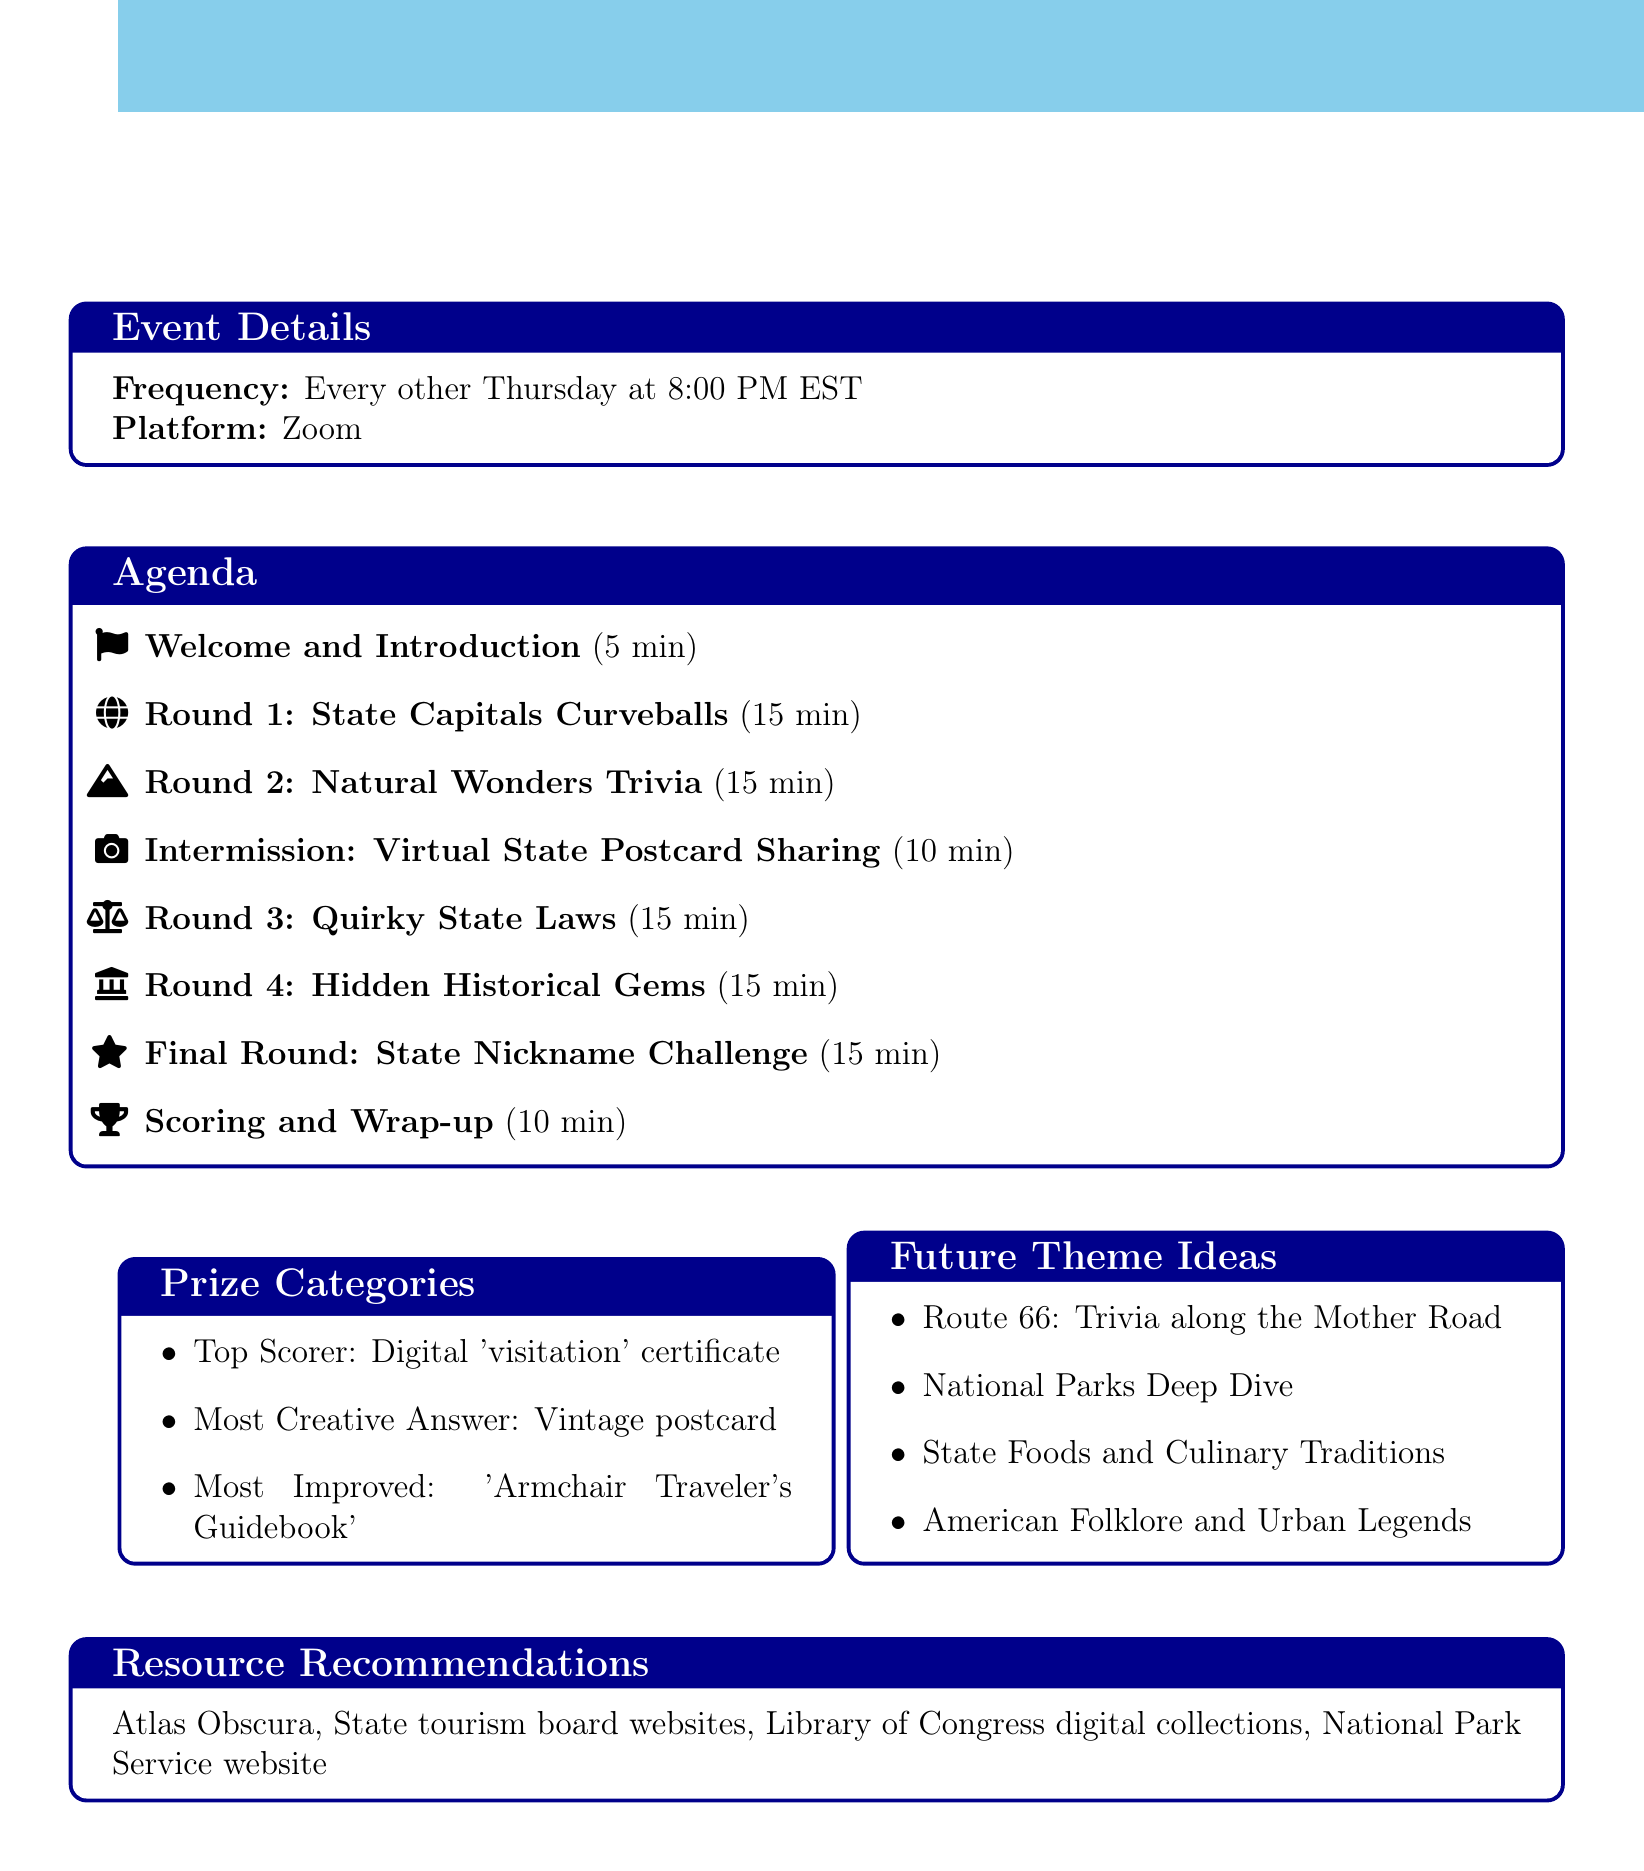What is the name of the event? The name of the event is stated in the document's title.
Answer: State Secrets: Bi-Weekly U.S. Trivia Night How often does the event occur? The frequency of the event is specified in the details section.
Answer: Every other Thursday What platform is used for the trivia night? The document mentions the platform for hosting the event.
Answer: Zoom How long is the intermission? The duration of the intermission is listed in the agenda items.
Answer: 10 minutes What is the prize for the top scorer? The document specifies the prize for top performers in the trivia night.
Answer: Digital 'visitation' certificate for the state of their choice What is one future theme idea mentioned? The document provides suggestions for future trivia night themes.
Answer: Route 66: Trivia along the Mother Road Which round focuses on quirky laws? The title of the round that deals with unusual state legislation is included in the agenda.
Answer: Round 3: Quirky State Laws What is the total duration of the trivia rounds? The total duration can be calculated by summing the minutes of each trivia round.
Answer: 60 minutes What is recommended for unusual attractions? The document lists resources for participants, including suggestions for specific types of information.
Answer: Atlas Obscura website 